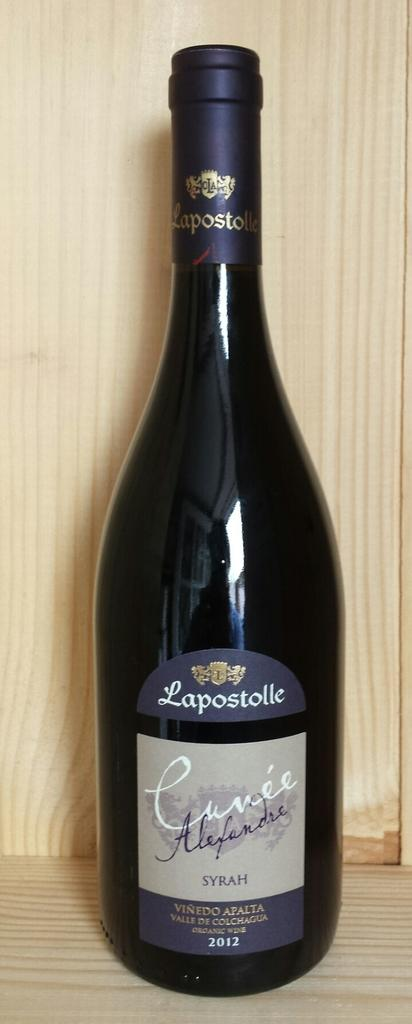<image>
Offer a succinct explanation of the picture presented. A bottle of wine from 2012 bears the name Lapostolle. 